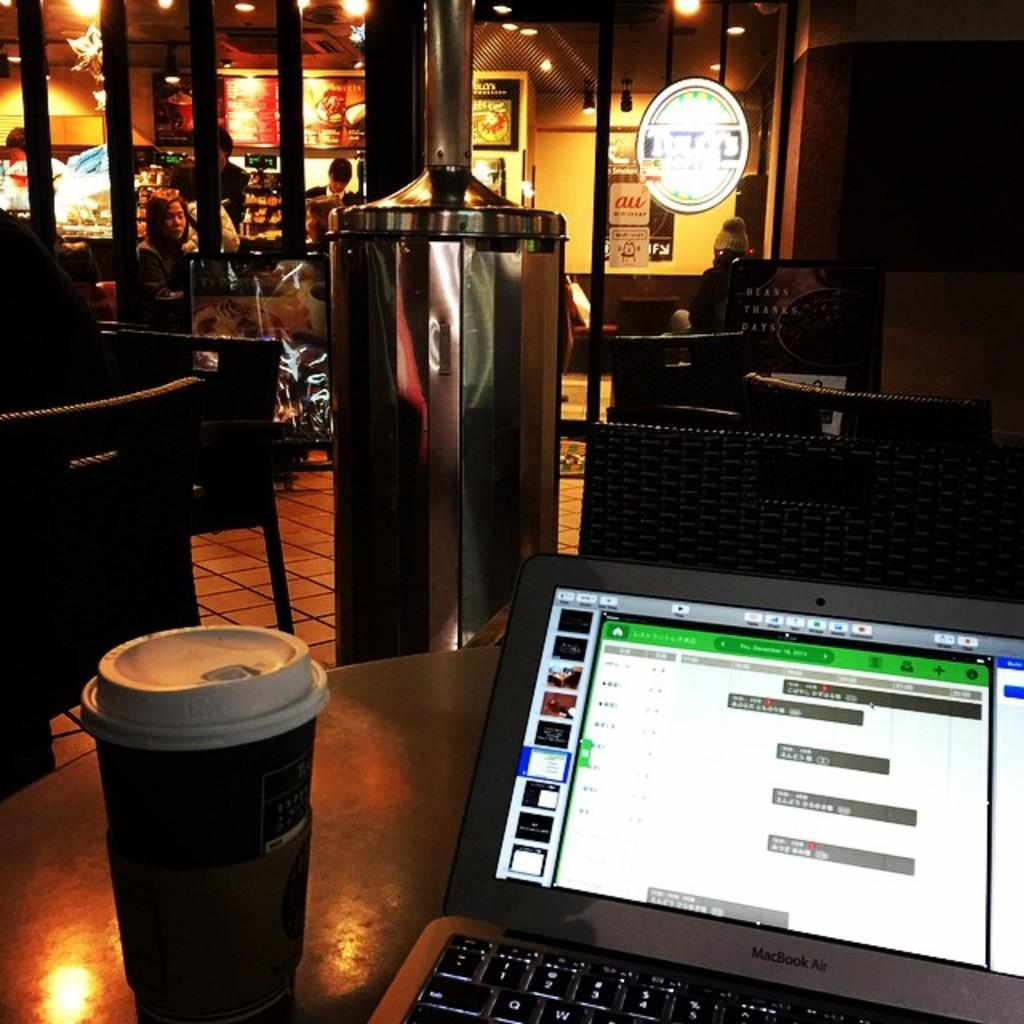<image>
Present a compact description of the photo's key features. Macbook air laptop open with a cup of coffee beside it 